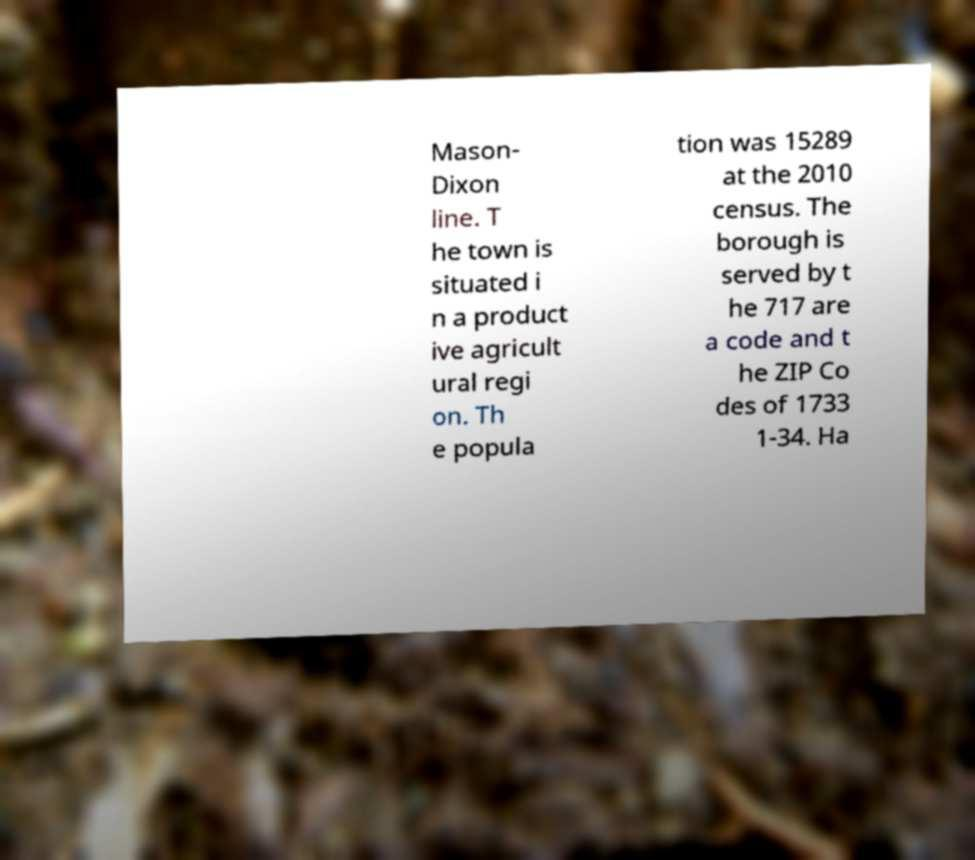Could you assist in decoding the text presented in this image and type it out clearly? Mason- Dixon line. T he town is situated i n a product ive agricult ural regi on. Th e popula tion was 15289 at the 2010 census. The borough is served by t he 717 are a code and t he ZIP Co des of 1733 1-34. Ha 